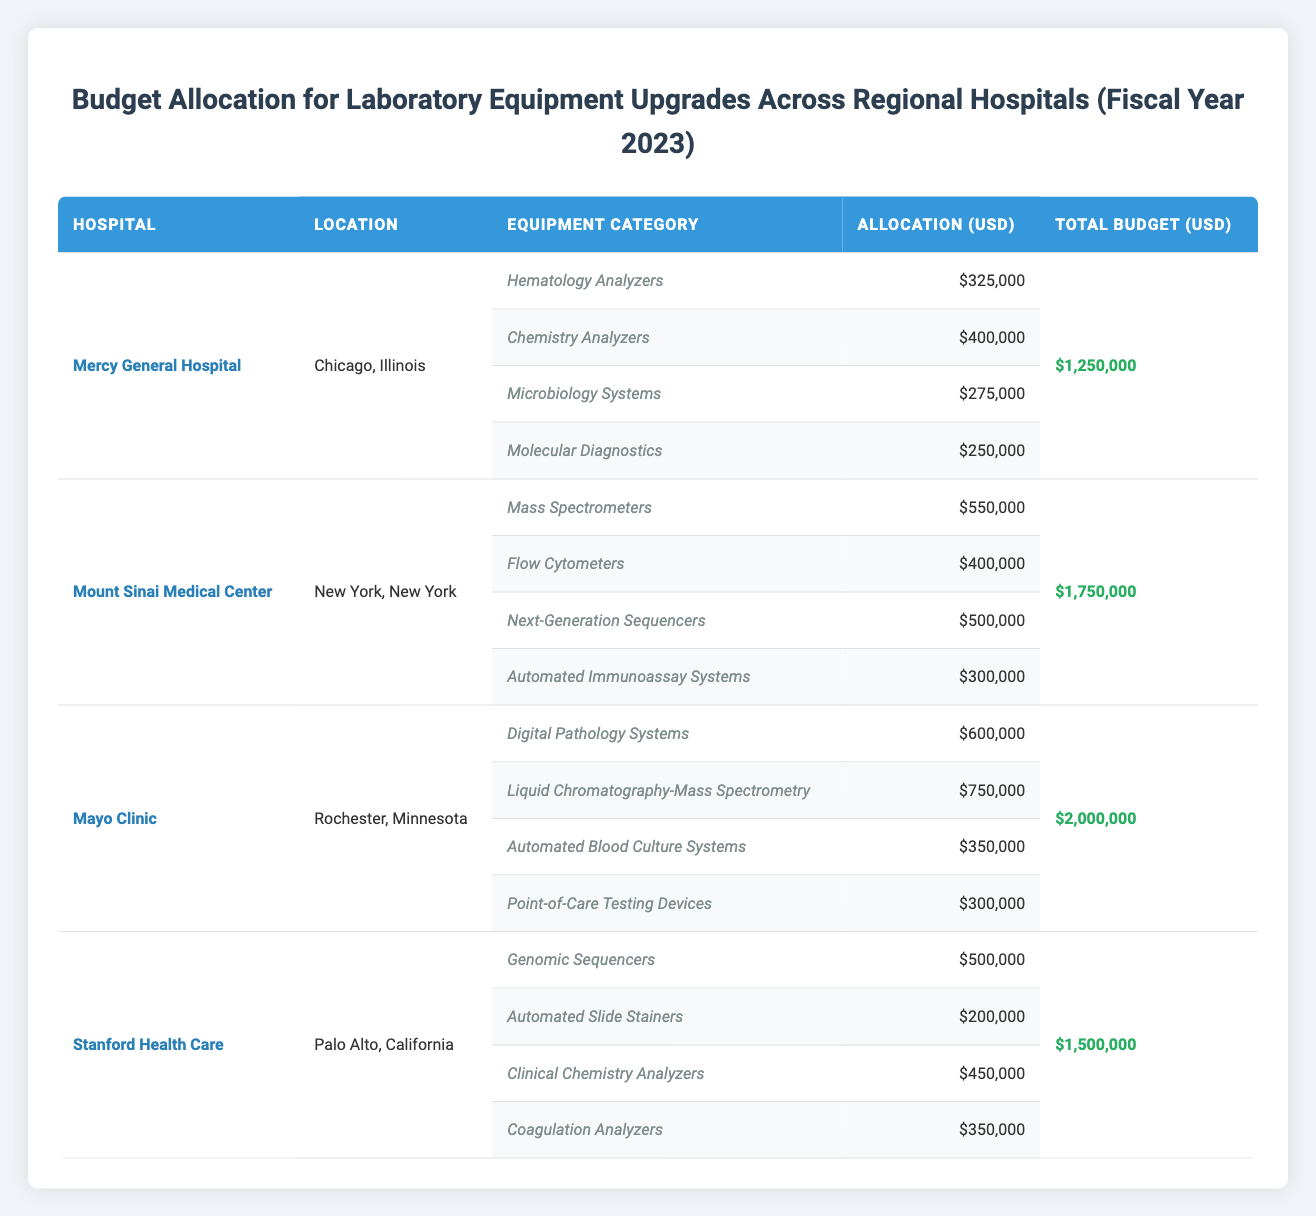What is the total budget allocated for Mayo Clinic? The total budget for Mayo Clinic can be directly found in the table under the "Total Budget" column for that hospital, which shows $2,000,000.
Answer: 2,000,000 Which hospital has the highest allocation for Microbiology Systems? There are multiple hospitals that have allocated funds for Microbiology Systems. The table shows that only Mercy General Hospital has an allocation of $275,000 specifically for this category. Therefore, Mercy General Hospital has the highest allocation for this equipment.
Answer: Mercy General Hospital How much more is allocated for Chemistry Analyzers compared to Coagulation Analyzers? From the table, Mercy General Hospital has an allocation of $400,000 for Chemistry Analyzers, while Stanford Health Care has $350,000 for Coagulation Analyzers. The difference can be calculated as $400,000 - $350,000 = $50,000.
Answer: 50,000 Is the total budget for Mount Sinai Medical Center greater than the combined allocations for Automated Immunoassay Systems and Mass Spectrometers? First, we need to check the total budget for Mount Sinai Medical Center, which is $1,750,000. The combined allocation for Automated Immunoassay Systems ($300,000) and Mass Spectrometers ($550,000) is $300,000 + $550,000 = $850,000. Since $1,750,000 is greater than $850,000, the answer is yes.
Answer: Yes What is the average allocation for laboratory equipment categories across all hospitals? First, we need to calculate the total allocations for all equipment categories. For Mercy General Hospital, the total is $325,000 + $400,000 + $275,000 + $250,000 = $1,250,000. For Mount Sinai Medical Center, it is $550,000 + $400,000 + $500,000 + $300,000 = $1,750,000. For Mayo Clinic, it is $600,000 + $750,000 + $350,000 + $300,000 = $2,000,000. For Stanford Health Care, it is $500,000 + $200,000 + $450,000 + $350,000 = $1,500,000. The total allocations for all hospitals is $1,250,000 + $1,750,000 + $2,000,000 + $1,500,000 = $6,500,000. Since there are 16 categories (4 for each of the 4 hospitals), the average allocation is $6,500,000 / 16 = $406,250.
Answer: 406,250 